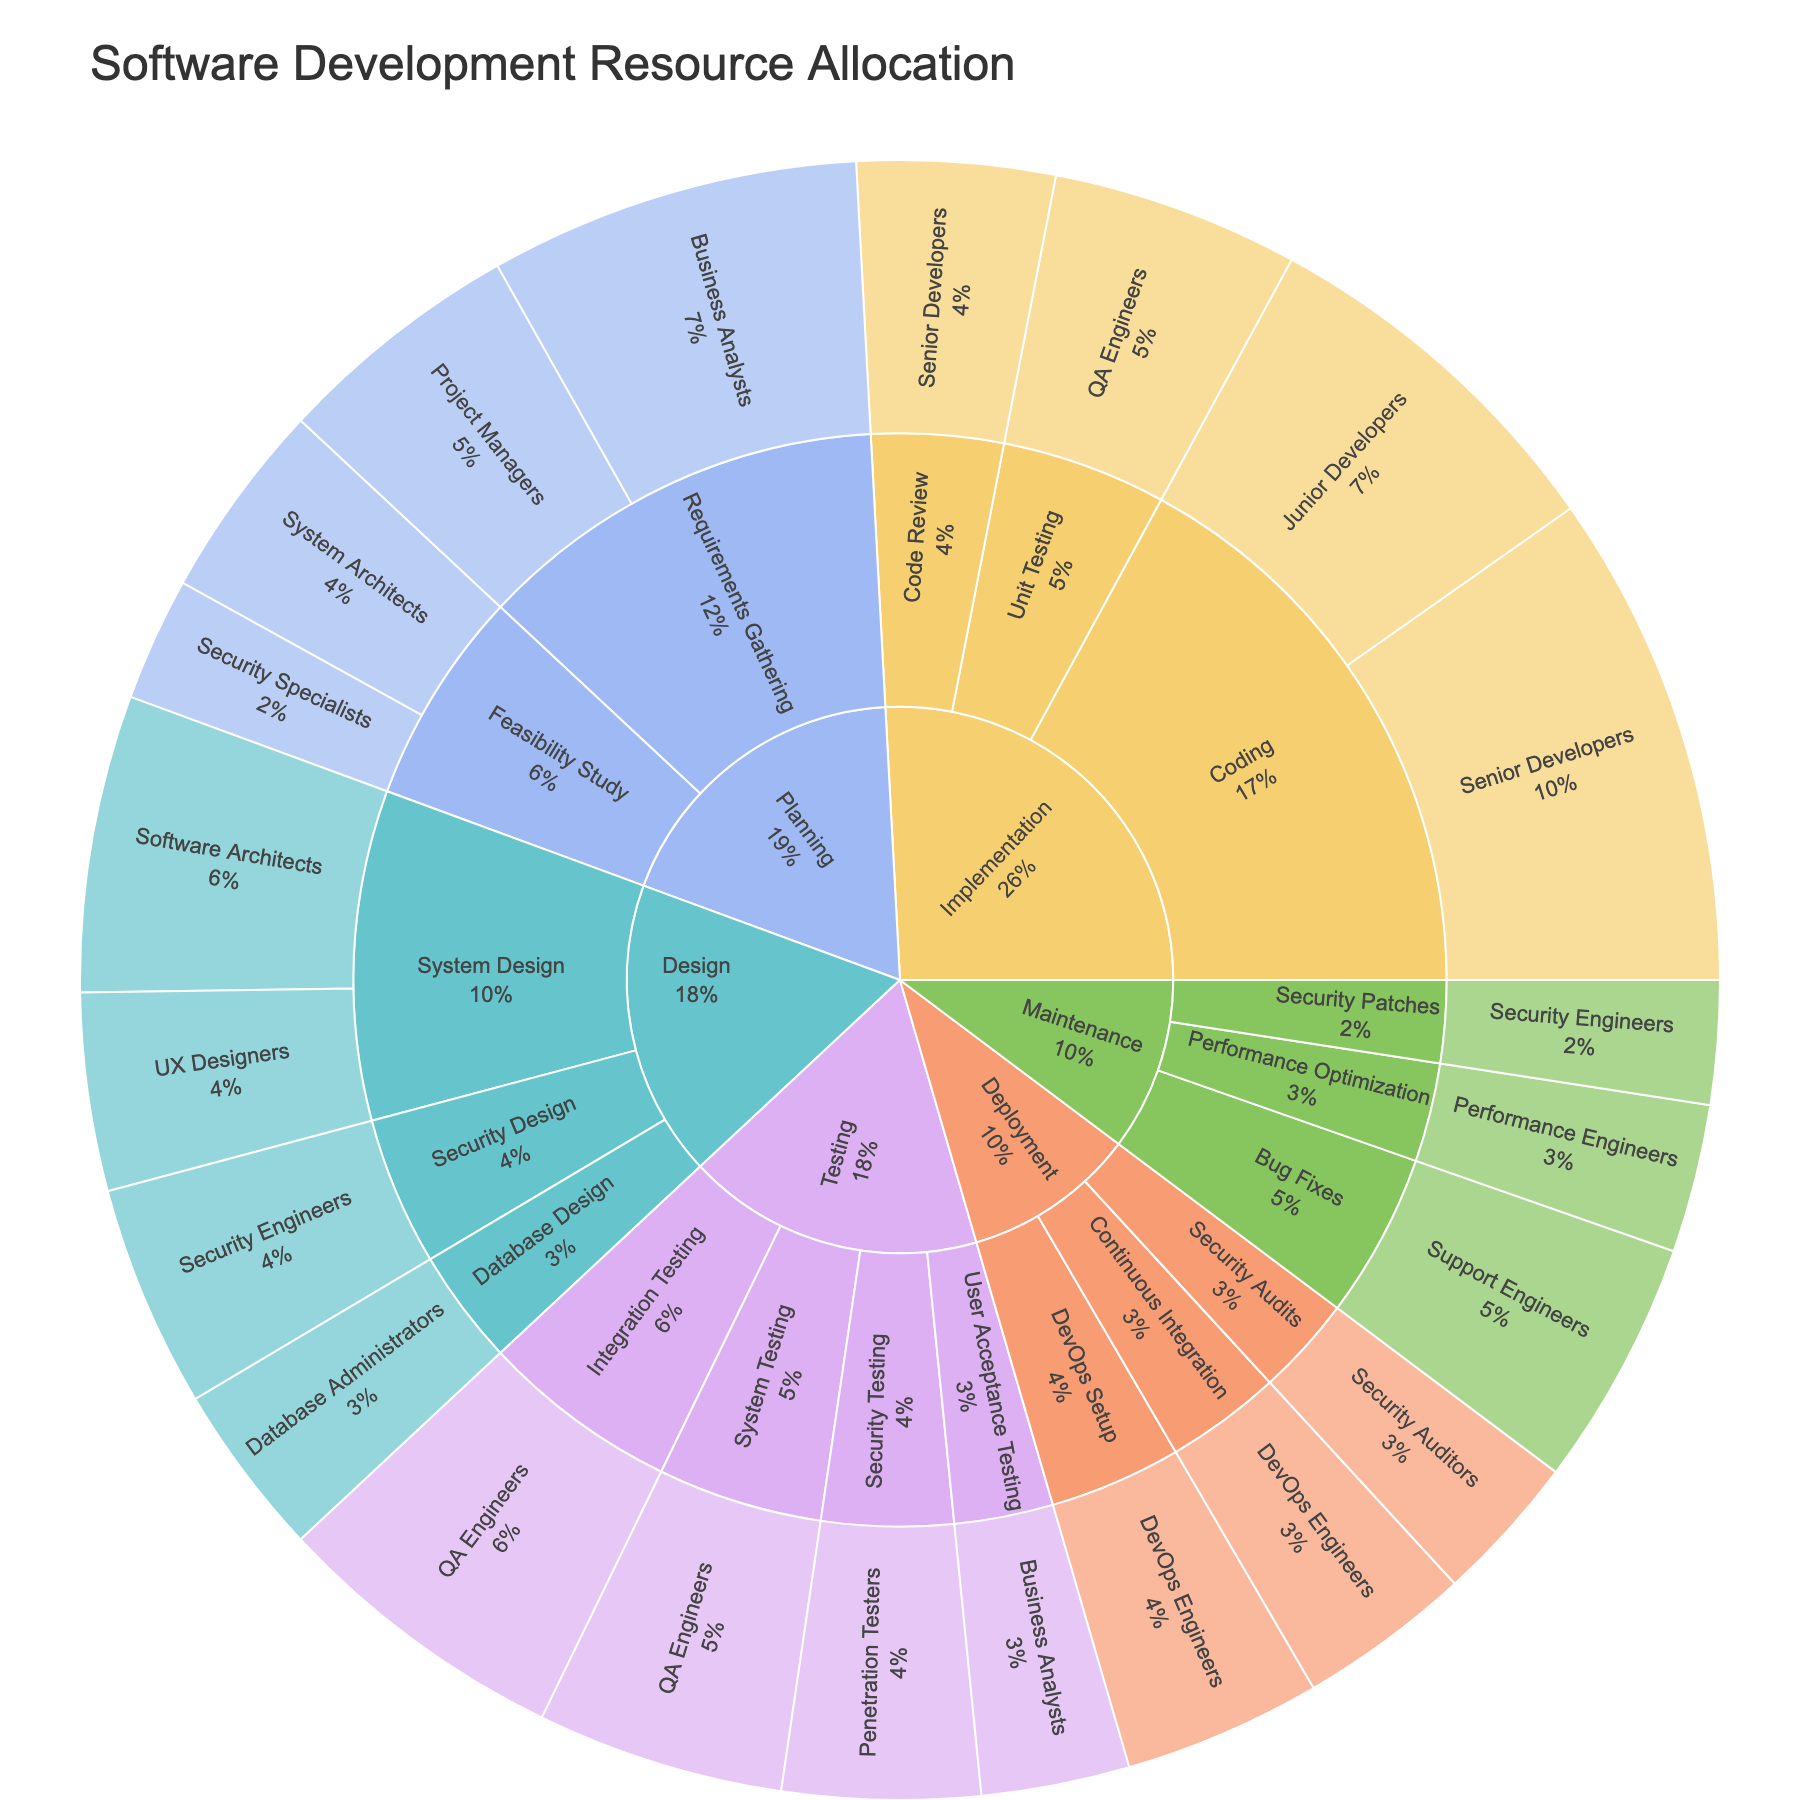what is the title of the sunburst plot? The title of the plot is displayed at the top. It reads "Software Development Resource Allocation".
Answer: Software Development Resource Allocation How much allocation is given to Security Engineers in the Design phase? The sunburst segments dedicated to Security Engineers in the Design phase can be identified by following the labels from the outer circle to the inner circle. Security Engineers have an allocation of 9 in the Design phase.
Answer: 9 What is the total allocation for Implementation phase? Sum up the allocations allocated to each resource under the Implementation phase. That includes Senior Developers (20), Junior Developers (15), QA Engineers (10), Senior Developers for Code Review (8). Sum is 20 + 15 + 10 + 8 = 53.
Answer: 53 Which stage has the highest resource allocation? Compare the total allocations for each stage: Planning, Design, Implementation, Testing, Deployment, and Maintenance. Implementation is the highest with 53+8=61.
Answer: Implementation What is the proportion of resource allocation between Coding and Unit Testing within Implementation? Check the allocation values for Coding (Senior Developers and Junior Developers) and Unit Testing (QA Engineers) under Implementation phase in the plot. Coding is 35 (20+15) and Unit Testing is 10. So, the proportion is Coding:Unit Testing is 35:10.
Answer: 35:10 Which phases involve Security Specialists or Engineers across the SDLC? Identify the phases where Security Specialists or Engineers are mentioned: Feasibility Study in Planning phase, Security Design in Design phase, Security Testing in Testing phase, and Security Patches in Maintenance phase.
Answer: Feasibility Study, Security Design, Security Testing, Security Patches Are there more QA Engineers involved in Unit Testing or in System Testing? Identify the allocation values from the sunburst plot for QA Engineers in Unit Testing (10) and in System Testing (10), both values are equal.
Answer: Equal Within the Planning stage, which resource has the least allocation? Compare the allocations within the Planning stage for Business Analysts, Project Managers, System Architects, and Security Specialists from the sunburst plot. Security Specialists have the least allocation with 5.
Answer: Security Specialists What is the combined allocation for QA Engineers across the entire SDLC? Sum the allocations where QA Engineers are involved: Implementation (Unit Testing - 10), Testing (Integration Testing - 12, System Testing - 10), which results in 10 + 12 + 10 = 32.
Answer: 32 